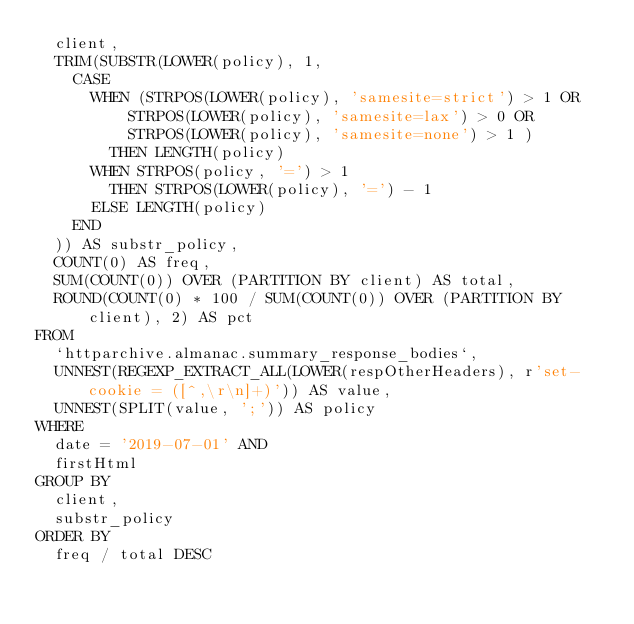<code> <loc_0><loc_0><loc_500><loc_500><_SQL_>  client,
  TRIM(SUBSTR(LOWER(policy), 1,
    CASE
      WHEN (STRPOS(LOWER(policy), 'samesite=strict') > 1 OR
          STRPOS(LOWER(policy), 'samesite=lax') > 0 OR
          STRPOS(LOWER(policy), 'samesite=none') > 1 )
        THEN LENGTH(policy)
      WHEN STRPOS(policy, '=') > 1
        THEN STRPOS(LOWER(policy), '=') - 1
      ELSE LENGTH(policy)
    END
  )) AS substr_policy,
  COUNT(0) AS freq,
  SUM(COUNT(0)) OVER (PARTITION BY client) AS total,
  ROUND(COUNT(0) * 100 / SUM(COUNT(0)) OVER (PARTITION BY client), 2) AS pct
FROM
  `httparchive.almanac.summary_response_bodies`,
  UNNEST(REGEXP_EXTRACT_ALL(LOWER(respOtherHeaders), r'set-cookie = ([^,\r\n]+)')) AS value,
  UNNEST(SPLIT(value, ';')) AS policy
WHERE
  date = '2019-07-01' AND
  firstHtml
GROUP BY
  client,
  substr_policy
ORDER BY
  freq / total DESC
</code> 